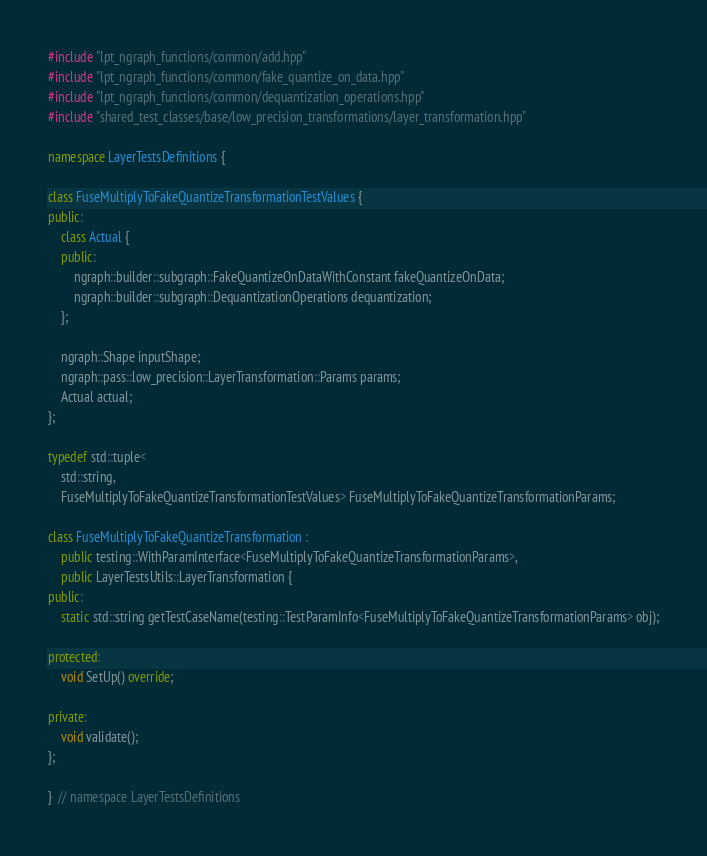Convert code to text. <code><loc_0><loc_0><loc_500><loc_500><_C++_>#include "lpt_ngraph_functions/common/add.hpp"
#include "lpt_ngraph_functions/common/fake_quantize_on_data.hpp"
#include "lpt_ngraph_functions/common/dequantization_operations.hpp"
#include "shared_test_classes/base/low_precision_transformations/layer_transformation.hpp"

namespace LayerTestsDefinitions {

class FuseMultiplyToFakeQuantizeTransformationTestValues {
public:
    class Actual {
    public:
        ngraph::builder::subgraph::FakeQuantizeOnDataWithConstant fakeQuantizeOnData;
        ngraph::builder::subgraph::DequantizationOperations dequantization;
    };

    ngraph::Shape inputShape;
    ngraph::pass::low_precision::LayerTransformation::Params params;
    Actual actual;
};

typedef std::tuple<
    std::string,
    FuseMultiplyToFakeQuantizeTransformationTestValues> FuseMultiplyToFakeQuantizeTransformationParams;

class FuseMultiplyToFakeQuantizeTransformation :
    public testing::WithParamInterface<FuseMultiplyToFakeQuantizeTransformationParams>,
    public LayerTestsUtils::LayerTransformation {
public:
    static std::string getTestCaseName(testing::TestParamInfo<FuseMultiplyToFakeQuantizeTransformationParams> obj);

protected:
    void SetUp() override;

private:
    void validate();
};

}  // namespace LayerTestsDefinitions
</code> 